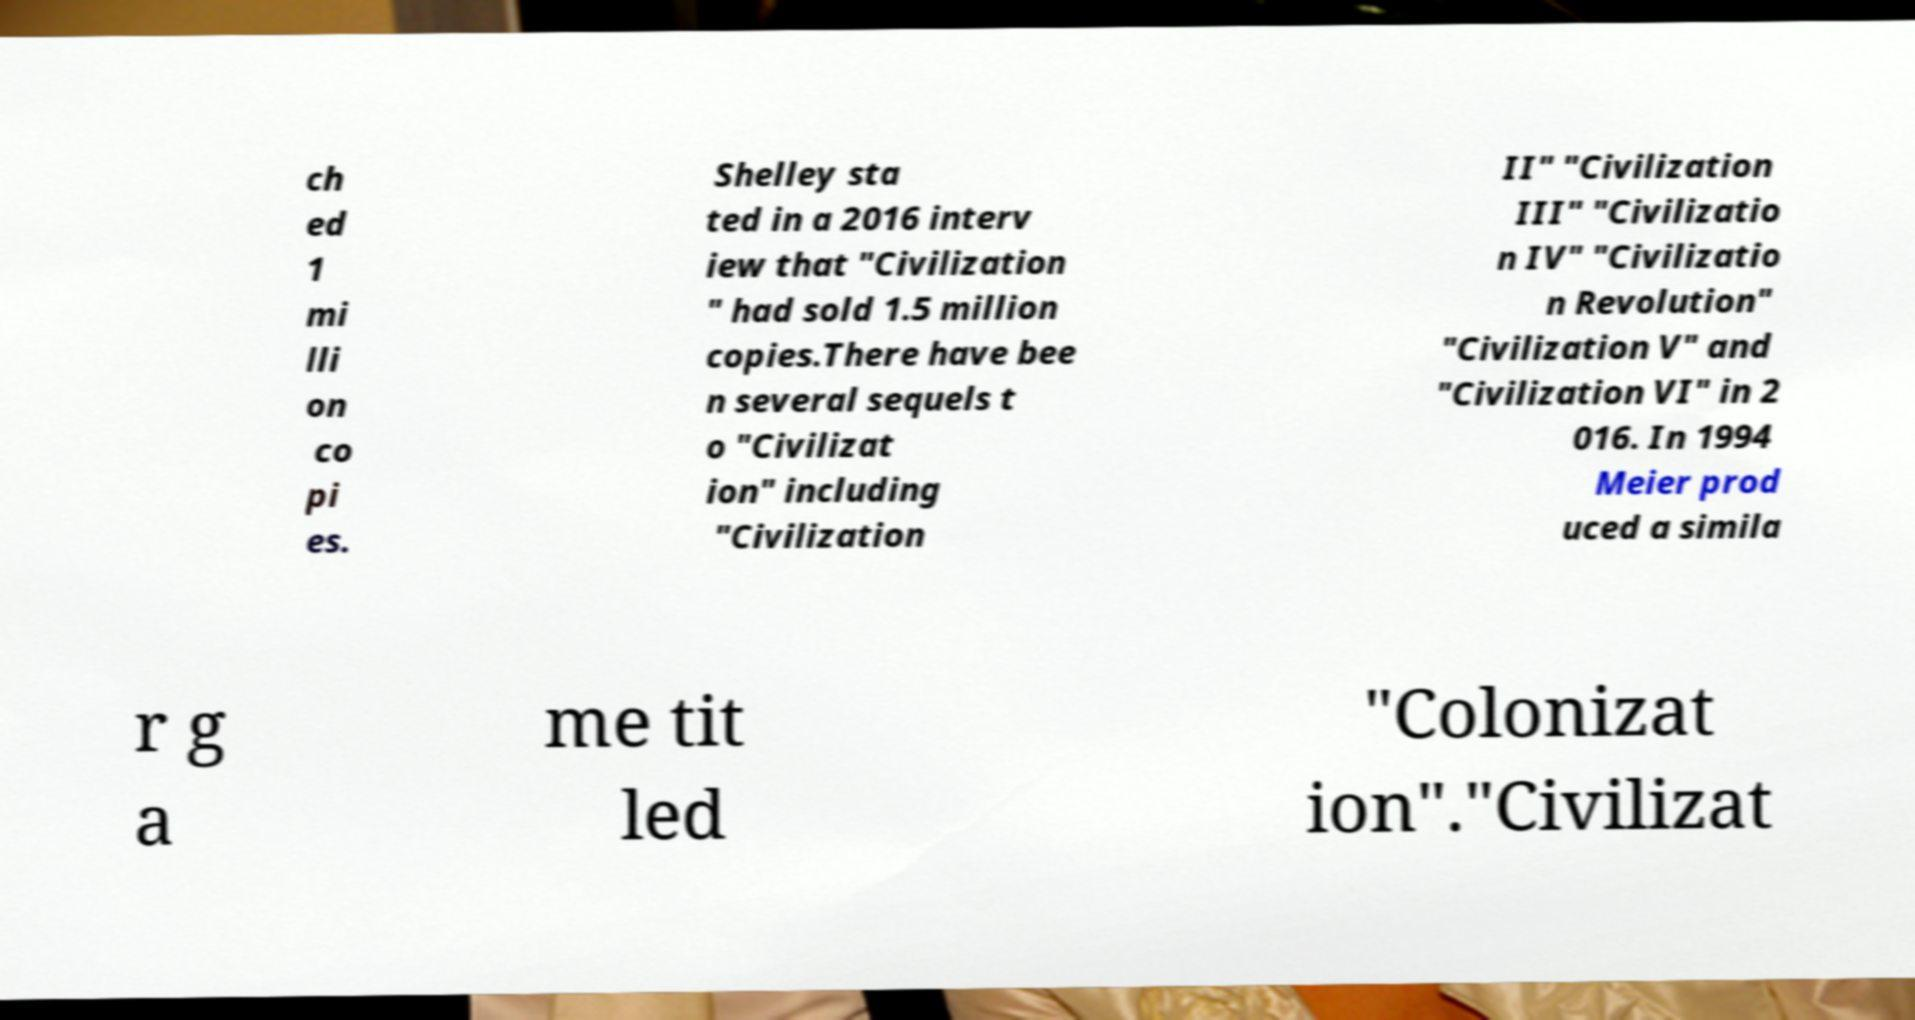For documentation purposes, I need the text within this image transcribed. Could you provide that? ch ed 1 mi lli on co pi es. Shelley sta ted in a 2016 interv iew that "Civilization " had sold 1.5 million copies.There have bee n several sequels t o "Civilizat ion" including "Civilization II" "Civilization III" "Civilizatio n IV" "Civilizatio n Revolution" "Civilization V" and "Civilization VI" in 2 016. In 1994 Meier prod uced a simila r g a me tit led "Colonizat ion"."Civilizat 